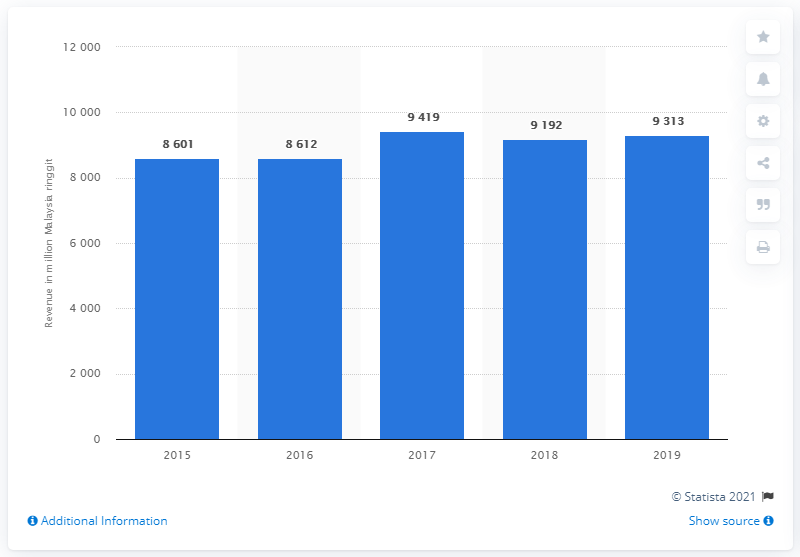Identify some key points in this picture. According to the information provided, Maxis Bhd's total revenue in 2018 was approximately RM9,192. Maxis Berhad reported total revenue of RM9,313 in Malaysia in 2019. 